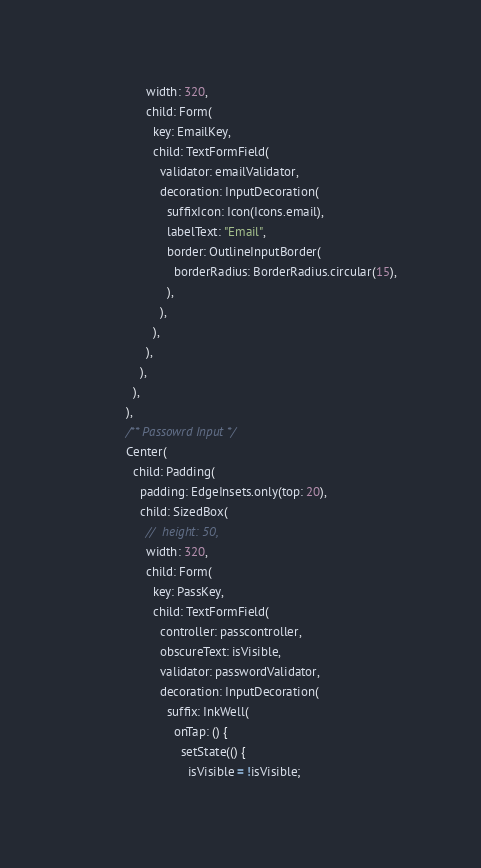Convert code to text. <code><loc_0><loc_0><loc_500><loc_500><_Dart_>                  width: 320,
                  child: Form(
                    key: EmailKey,
                    child: TextFormField(
                      validator: emailValidator,
                      decoration: InputDecoration(
                        suffixIcon: Icon(Icons.email),
                        labelText: "Email",
                        border: OutlineInputBorder(
                          borderRadius: BorderRadius.circular(15),
                        ),
                      ),
                    ),
                  ),
                ),
              ),
            ),
            /** Passowrd Input */
            Center(
              child: Padding(
                padding: EdgeInsets.only(top: 20),
                child: SizedBox(
                  //  height: 50,
                  width: 320,
                  child: Form(
                    key: PassKey,
                    child: TextFormField(
                      controller: passcontroller,
                      obscureText: isVisible,
                      validator: passwordValidator,
                      decoration: InputDecoration(
                        suffix: InkWell(
                          onTap: () {
                            setState(() {
                              isVisible = !isVisible;</code> 